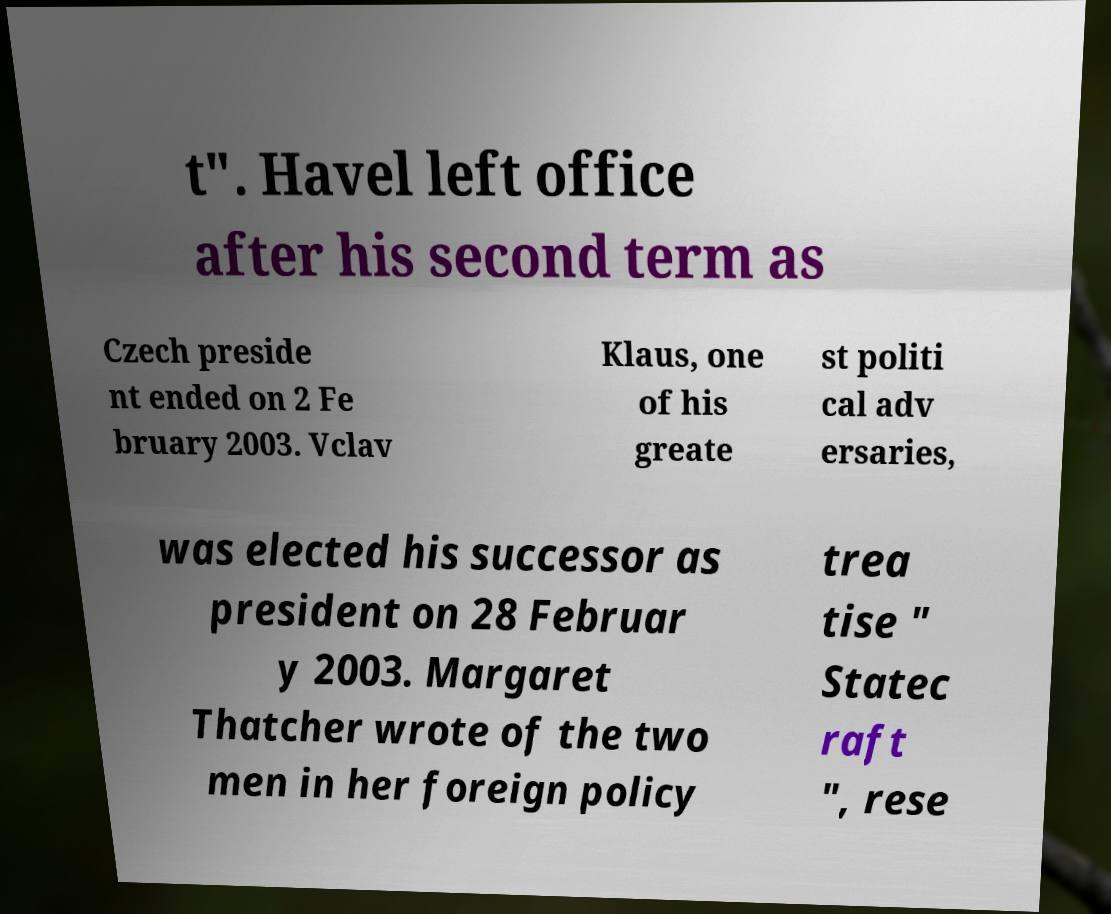Can you read and provide the text displayed in the image?This photo seems to have some interesting text. Can you extract and type it out for me? t". Havel left office after his second term as Czech preside nt ended on 2 Fe bruary 2003. Vclav Klaus, one of his greate st politi cal adv ersaries, was elected his successor as president on 28 Februar y 2003. Margaret Thatcher wrote of the two men in her foreign policy trea tise " Statec raft ", rese 